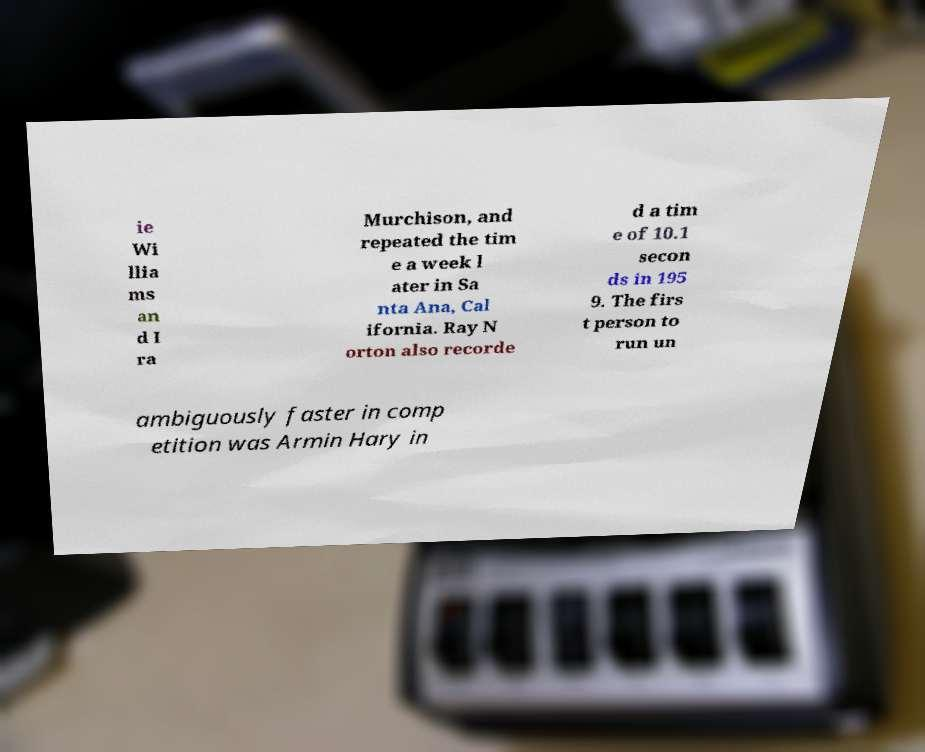Can you read and provide the text displayed in the image?This photo seems to have some interesting text. Can you extract and type it out for me? ie Wi llia ms an d I ra Murchison, and repeated the tim e a week l ater in Sa nta Ana, Cal ifornia. Ray N orton also recorde d a tim e of 10.1 secon ds in 195 9. The firs t person to run un ambiguously faster in comp etition was Armin Hary in 